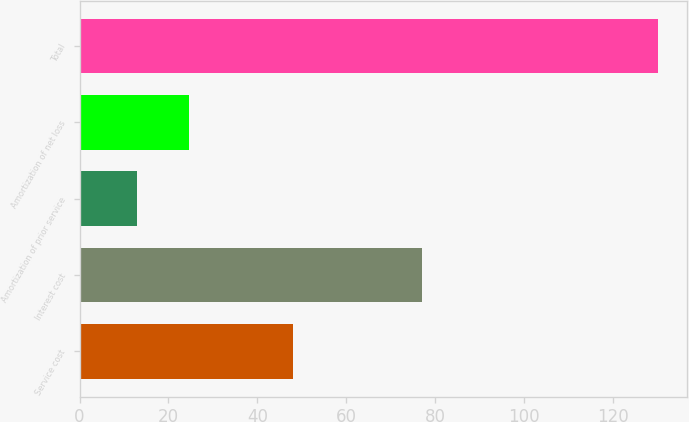<chart> <loc_0><loc_0><loc_500><loc_500><bar_chart><fcel>Service cost<fcel>Interest cost<fcel>Amortization of prior service<fcel>Amortization of net loss<fcel>Total<nl><fcel>48<fcel>77<fcel>13<fcel>24.7<fcel>130<nl></chart> 